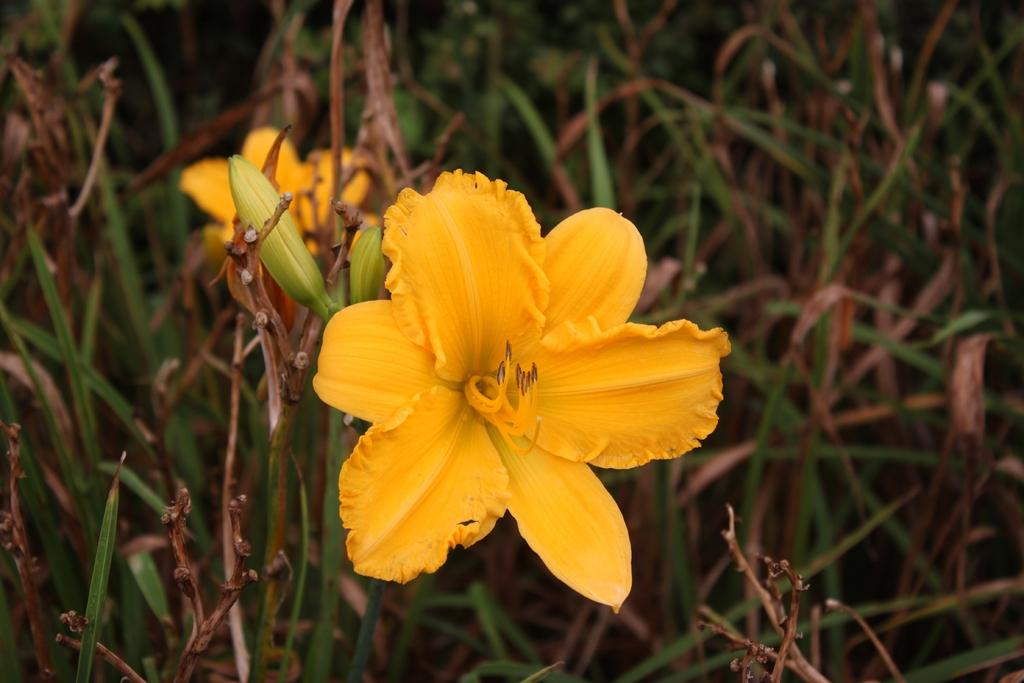What type of living organisms can be seen in the image? Flowers and plants can be seen in the image. Are there any unopened flowers in the image? Yes, there are buds in the image. What is the general category of these living organisms? They are plants. What type of jewel can be seen in the image? There is no jewel present in the image; it features flowers and plants. What emotion might be associated with the flowers in the image? The image does not convey any specific emotions, such as regret. 